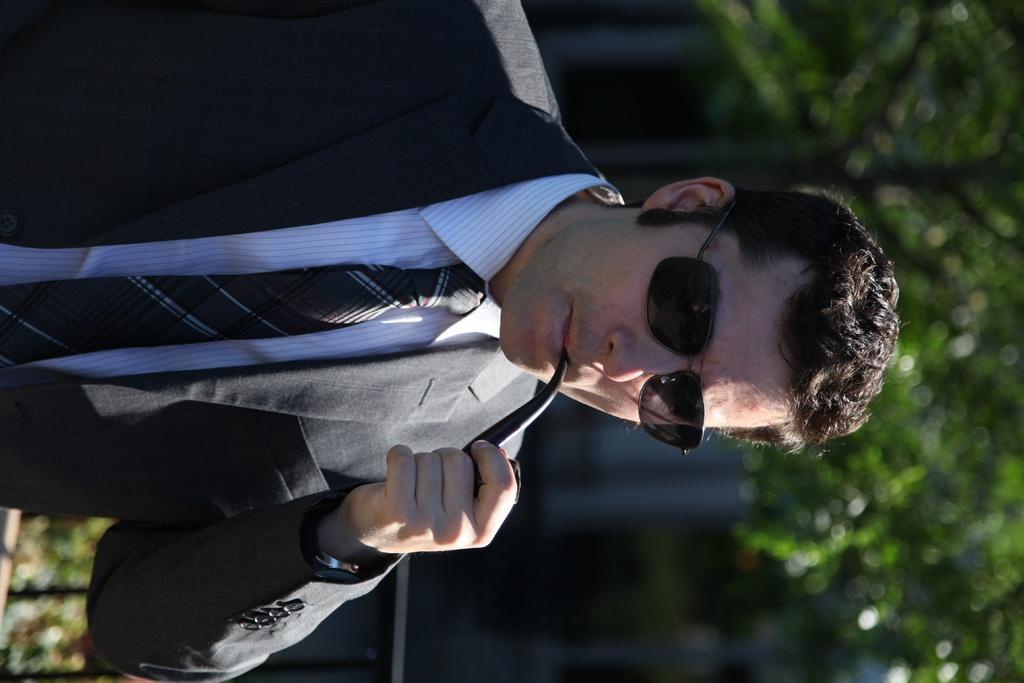How is the image oriented? The image is tilted. What is the main subject of the image? There is a man in the image. What is the man wearing? The man is wearing a suit and goggles. What activity is the man engaged in? The man is smoking. How would you describe the background of the image? The background behind the man is blurry. Can you see any boats in the harbor behind the man in the image? There is no harbor or boats present in the image. Is the man wearing a winter coat in the image? The man is wearing a suit, not a winter coat, in the image. 